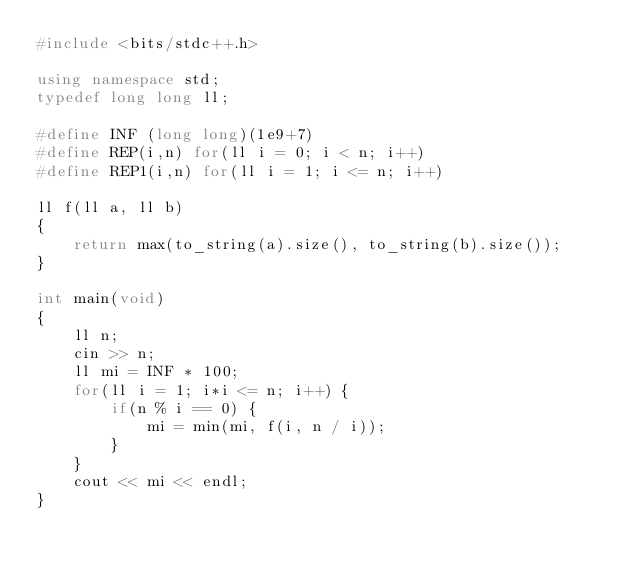<code> <loc_0><loc_0><loc_500><loc_500><_C++_>#include <bits/stdc++.h>

using namespace std;
typedef long long ll;

#define INF (long long)(1e9+7)
#define REP(i,n) for(ll i = 0; i < n; i++)
#define REP1(i,n) for(ll i = 1; i <= n; i++)

ll f(ll a, ll b)
{
    return max(to_string(a).size(), to_string(b).size());
}

int main(void)
{
    ll n;
    cin >> n;
    ll mi = INF * 100;
    for(ll i = 1; i*i <= n; i++) {
        if(n % i == 0) {
            mi = min(mi, f(i, n / i));
        }
    }
    cout << mi << endl;
}
</code> 